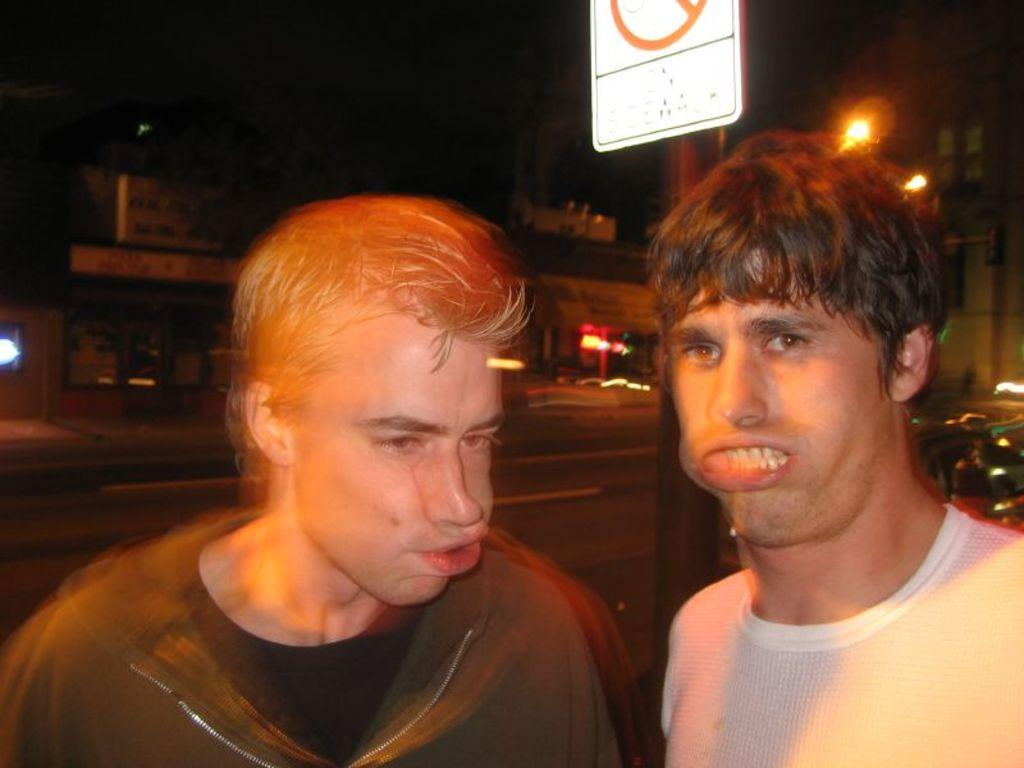Who or what is present in the image? There are people in the image. What object can be seen in the image? There is a pole in the image. What can be seen in the distance in the image? There are lights and houses visible in the background of the image. What type of camera is being used by the people in the image? There is no camera visible in the image, and it is not mentioned that the people are using one. 